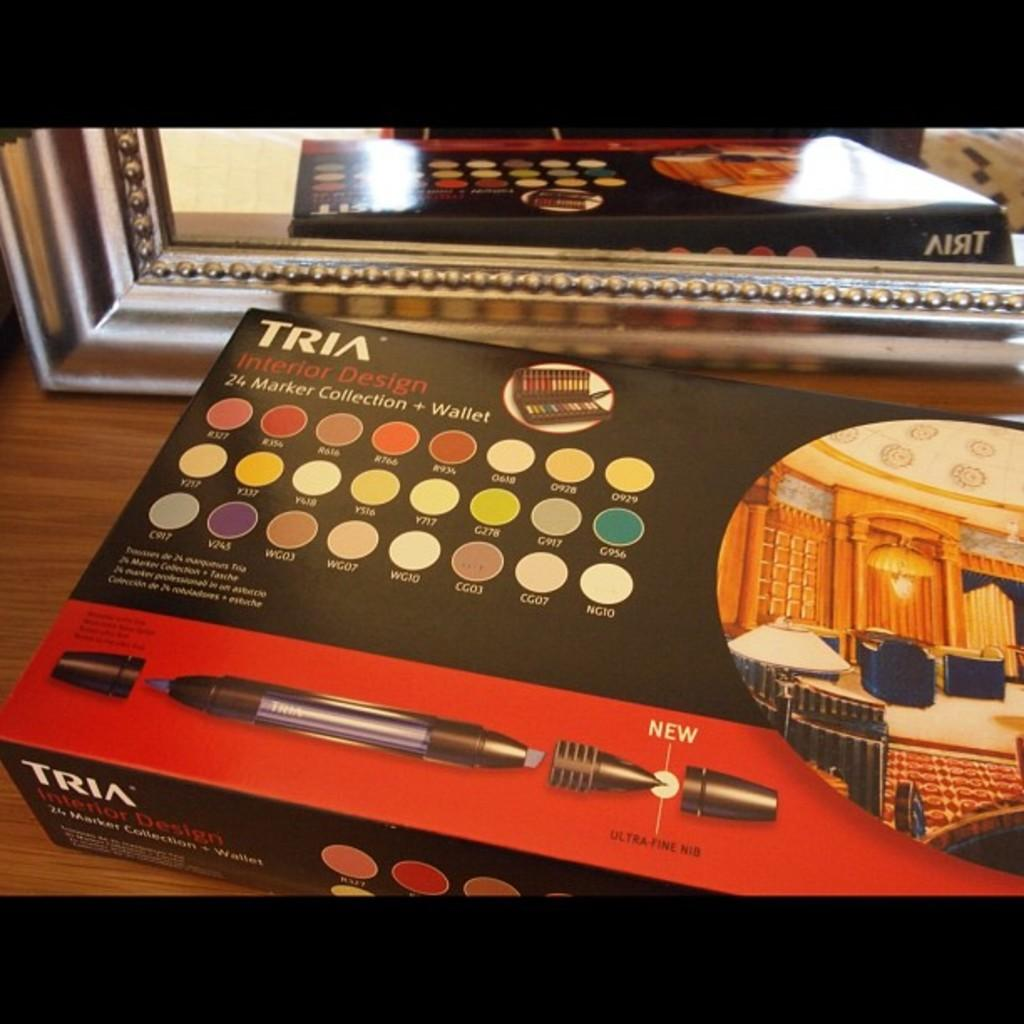<image>
Render a clear and concise summary of the photo. 24 colored interior design marker collection and wallet by Tria 